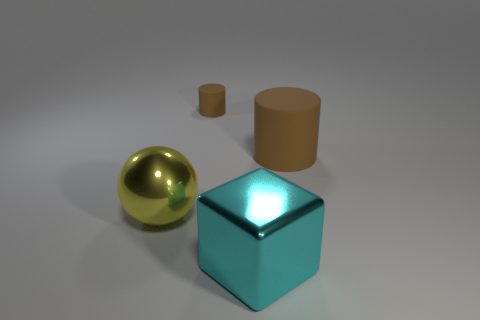Do the big sphere and the cylinder that is right of the large cyan object have the same material?
Provide a succinct answer. No. What is the ball made of?
Your answer should be compact. Metal. What shape is the large yellow thing that is made of the same material as the large cube?
Offer a very short reply. Sphere. What number of other things are there of the same shape as the yellow shiny object?
Make the answer very short. 0. There is a large cyan thing; what number of large spheres are in front of it?
Your answer should be compact. 0. There is a cylinder that is on the left side of the big metallic block; is it the same size as the metallic object that is on the right side of the metal sphere?
Give a very brief answer. No. How many other objects are there of the same size as the yellow metallic ball?
Keep it short and to the point. 2. There is a thing that is left of the rubber cylinder to the left of the matte thing in front of the tiny brown thing; what is its material?
Make the answer very short. Metal. Do the yellow object and the metal object on the right side of the big sphere have the same size?
Offer a terse response. Yes. How big is the thing that is both behind the large yellow shiny ball and right of the tiny matte object?
Offer a terse response. Large. 